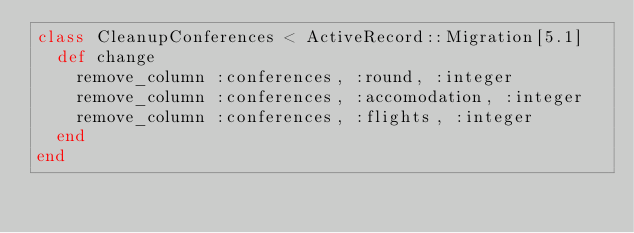<code> <loc_0><loc_0><loc_500><loc_500><_Ruby_>class CleanupConferences < ActiveRecord::Migration[5.1]
  def change
    remove_column :conferences, :round, :integer
    remove_column :conferences, :accomodation, :integer
    remove_column :conferences, :flights, :integer
  end
end
</code> 